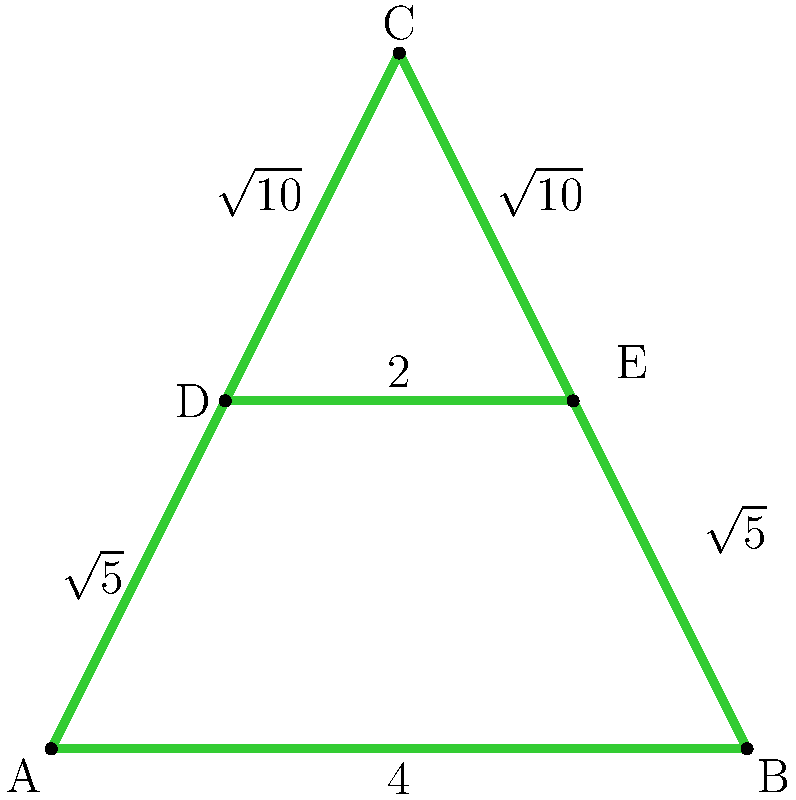Yo, check out this wild graffiti-style letter "A" on the wall! It's made up of straight lines forming a shape like in the diagram. If you want to outline this masterpiece with spray paint, how much length do you need to cover? In other words, what's the perimeter of this dope "A"? Alright, let's break this down step by step, homie:

1) First, we need to identify all the sides of this "A":
   - Bottom side AB: 4 units
   - Middle horizontal DE: 2 units
   - Left side AD: $\sqrt{5}$ units
   - Right side BE: $\sqrt{5}$ units
   - Upper left DC: $\sqrt{10}$ units
   - Upper right EC: $\sqrt{10}$ units

2) To find the perimeter, we just need to add up all these sides:

   $\text{Perimeter} = 4 + 2 + \sqrt{5} + \sqrt{5} + \sqrt{10} + \sqrt{10}$

3) Let's simplify:
   $\text{Perimeter} = 6 + 2\sqrt{5} + 2\sqrt{10}$

4) We can't simplify this further because $\sqrt{5}$ and $\sqrt{10}$ are irrational numbers that can't be combined.

So, the final perimeter is $6 + 2\sqrt{5} + 2\sqrt{10}$ units.
Answer: $6 + 2\sqrt{5} + 2\sqrt{10}$ units 